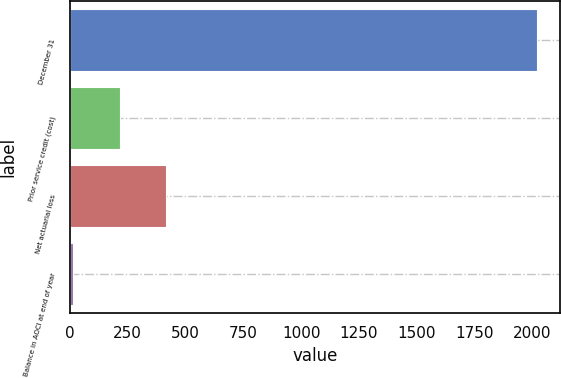Convert chart. <chart><loc_0><loc_0><loc_500><loc_500><bar_chart><fcel>December 31<fcel>Prior service credit (cost)<fcel>Net actuarial loss<fcel>Balance in AOCI at end of year<nl><fcel>2018<fcel>215.3<fcel>415.6<fcel>15<nl></chart> 